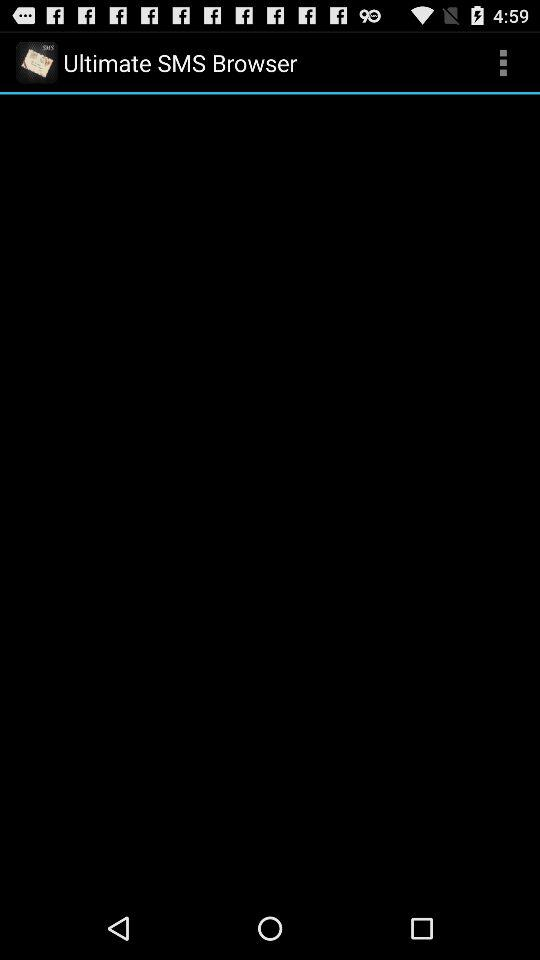What is the app name? The app name is "Ultimate SMS Browser". 